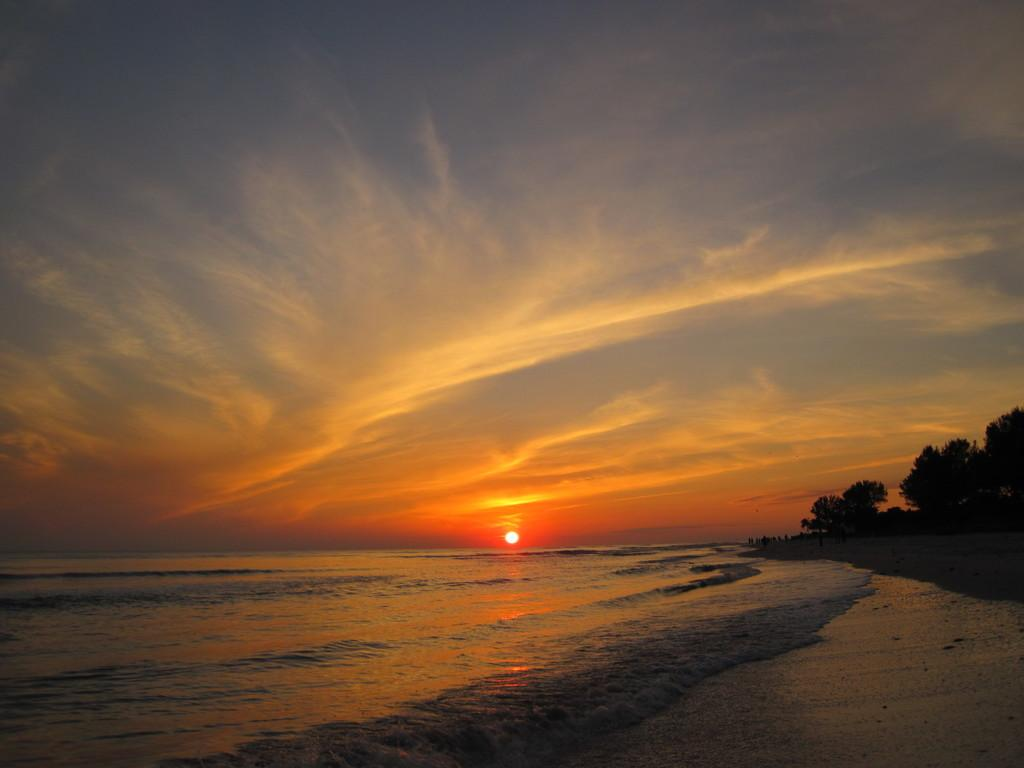What type of natural environment is depicted in the image? The image features a sea. What celestial body is visible in the image? The sun is visible in the image. What else can be seen in the sky? Clouds are present in the sky. What type of terrain is on the right side of the image? There is sand on the right side of the image. What else is on the right side of the image? There are persons and a tree on the right side of the image. How many lizards are sitting on the tree in the image? There are no lizards present in the image; only a tree and persons are visible on the right side of the image. What is the weight of the pear that is not in the image? There is no pear present in the image, so its weight cannot be determined. 